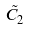Convert formula to latex. <formula><loc_0><loc_0><loc_500><loc_500>\tilde { C } _ { 2 }</formula> 